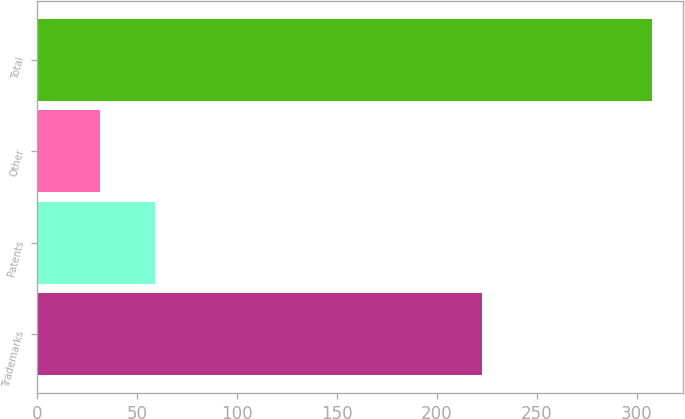Convert chart to OTSL. <chart><loc_0><loc_0><loc_500><loc_500><bar_chart><fcel>Trademarks<fcel>Patents<fcel>Other<fcel>Total<nl><fcel>222.4<fcel>59.14<fcel>31.5<fcel>307.9<nl></chart> 